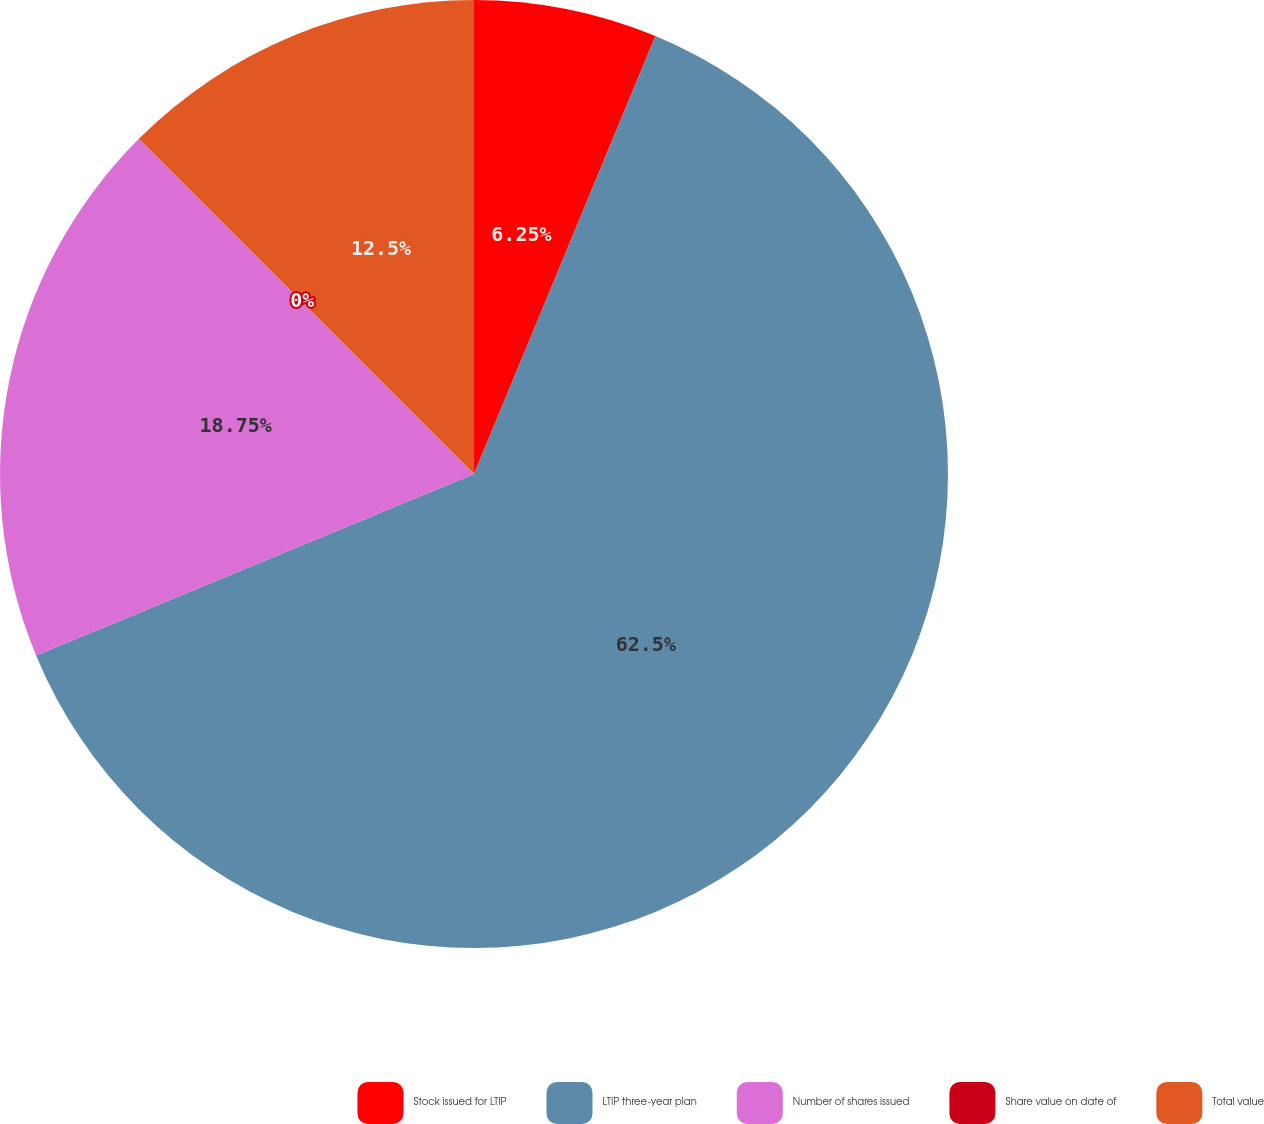Convert chart to OTSL. <chart><loc_0><loc_0><loc_500><loc_500><pie_chart><fcel>Stock issued for LTIP<fcel>LTIP three-year plan<fcel>Number of shares issued<fcel>Share value on date of<fcel>Total value<nl><fcel>6.25%<fcel>62.5%<fcel>18.75%<fcel>0.0%<fcel>12.5%<nl></chart> 